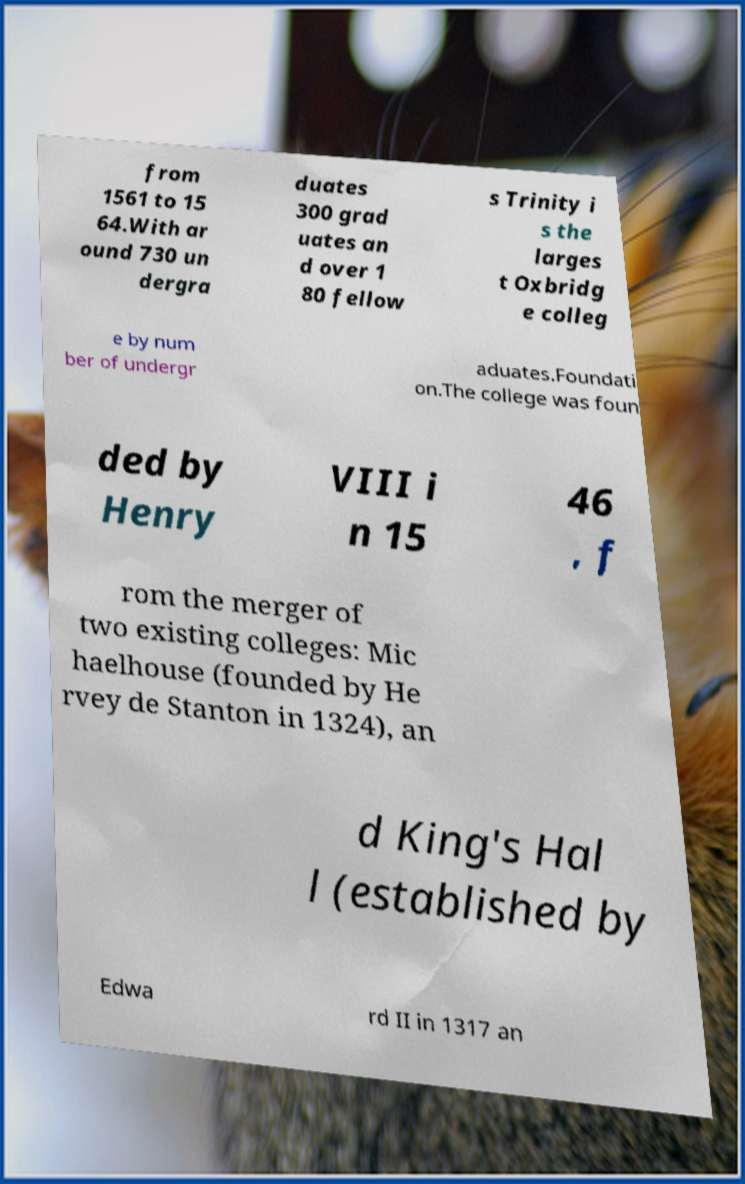Please identify and transcribe the text found in this image. from 1561 to 15 64.With ar ound 730 un dergra duates 300 grad uates an d over 1 80 fellow s Trinity i s the larges t Oxbridg e colleg e by num ber of undergr aduates.Foundati on.The college was foun ded by Henry VIII i n 15 46 , f rom the merger of two existing colleges: Mic haelhouse (founded by He rvey de Stanton in 1324), an d King's Hal l (established by Edwa rd II in 1317 an 